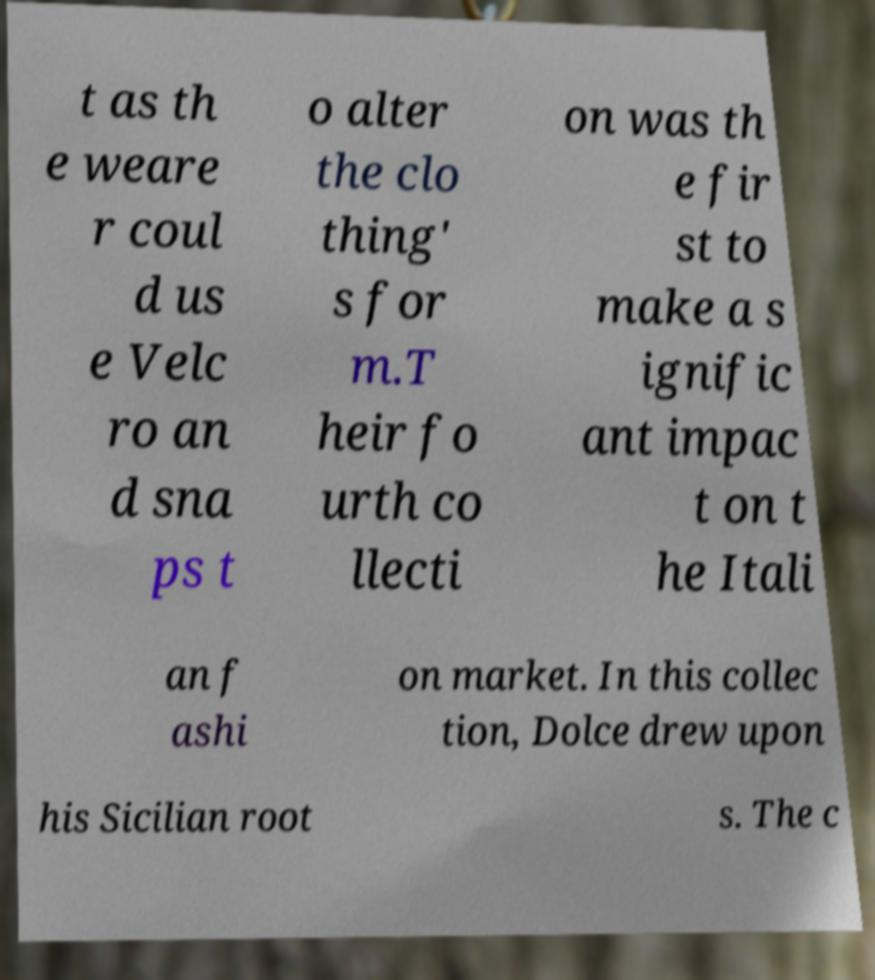Please read and relay the text visible in this image. What does it say? t as th e weare r coul d us e Velc ro an d sna ps t o alter the clo thing' s for m.T heir fo urth co llecti on was th e fir st to make a s ignific ant impac t on t he Itali an f ashi on market. In this collec tion, Dolce drew upon his Sicilian root s. The c 